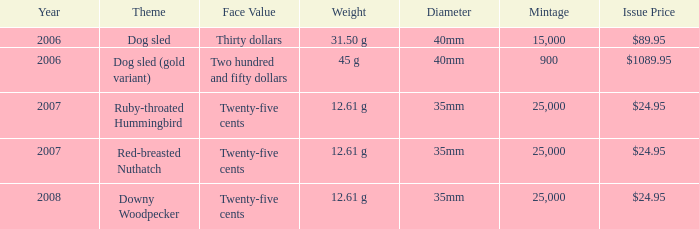61 g weight ruby-throated hummingbird? 1.0. 